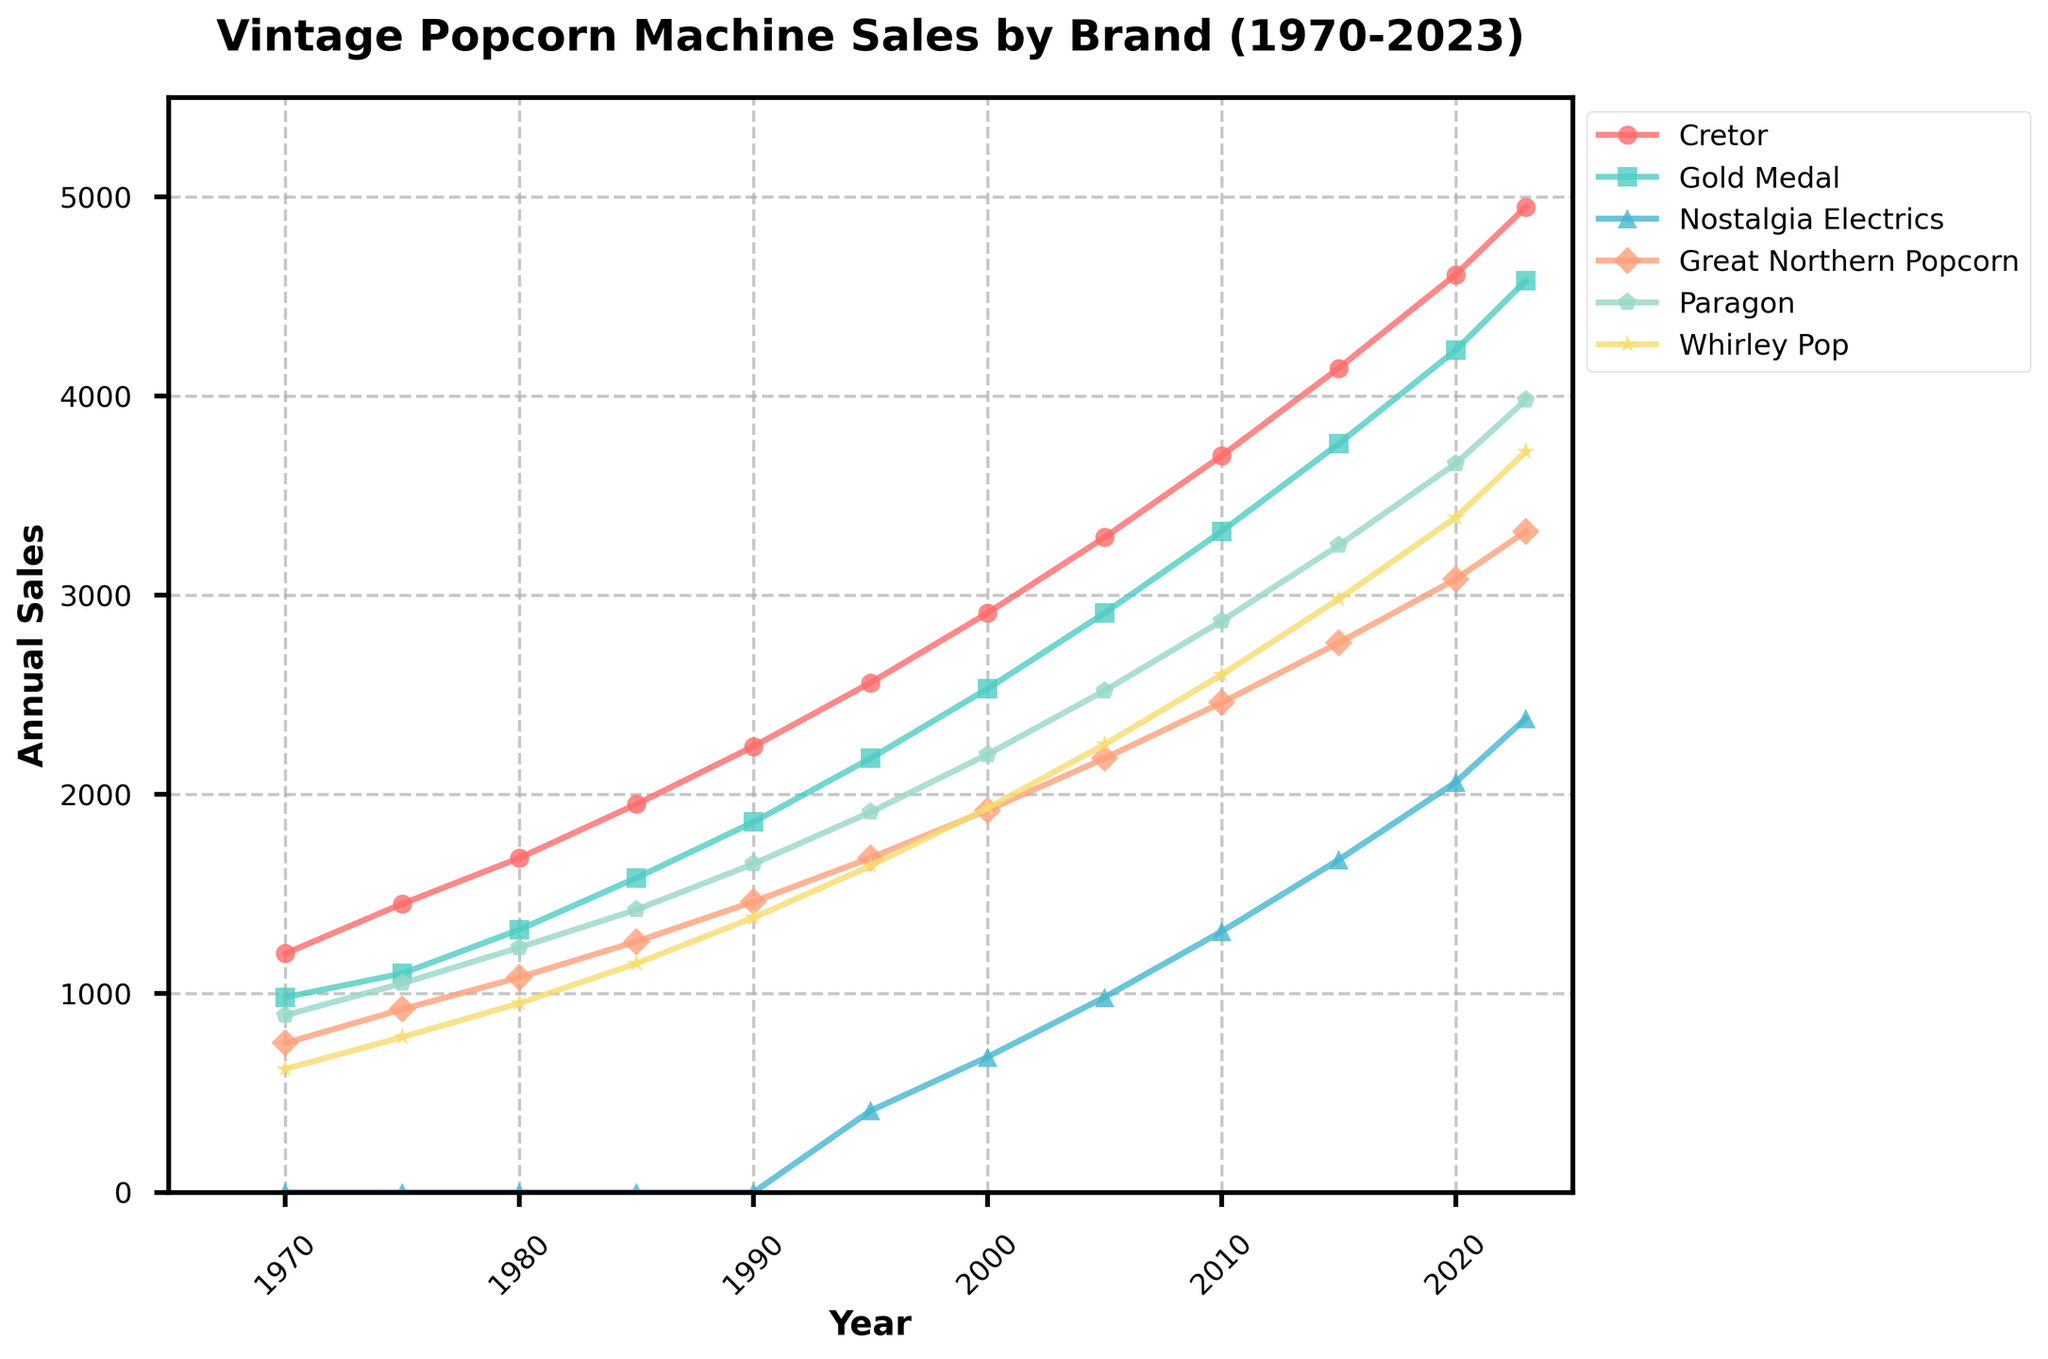Which brand had the highest sales in 2023? Look at the values at the end of each line on the right side of the chart. The highest value is for Cretor.
Answer: Cretor Between 2000 and 2010, which brand saw the largest increase in sales? Examine the lines for each brand between the years 2000 and 2010. Calculate the difference in sales for each brand. Cretor increased from 2910 to 3700, which is the largest difference.
Answer: Cretor How many brands were introduced after 1990? Track the lines starting after 1990. Only Nostalgia Electrics appears after 1990.
Answer: 1 Which brand had the most consistent sales growth over the years? Look for the line that has a steady slope without any sudden spikes or drops. Cretor has the most consistent growth pattern.
Answer: Cretor What was the combined sales of Gold Medal and Paragon in 2015? Find the sales of Gold Medal and Paragon in 2015 on the chart. Gold Medal: 3760 and Paragon: 3250. Combined = 3760 + 3250
Answer: 7010 Did any brand experience a decline in sales at any point? Trace each brand’s line to see if any of them dip downward at any point. None of the brands show a decline; all lines are either stable or upward.
Answer: No Which brand's sales were closest to 3000 in 2010? Look at the 2010 data points: Cretor (3700), Gold Medal (3320), Nostalgia Electrics (1310), Great Northern Popcorn (2460), Paragon (2870), Whirley Pop (2600). The closest to 3000 is Paragon at 2870.
Answer: Paragon What is the difference in sales between the highest and lowest selling brands in 2005? Find the highest and the lowest sales figures in 2005. Cretor (3290) and Nostalgia Electrics (980). The difference is 3290 - 980.
Answer: 2310 Between which years did Whirley Pop see the largest increase in sales? Study the Whirley Pop line and calculate the differences across years. The largest increase is between 2010 (2600) and 2015 (2980), which is 380.
Answer: 2010 to 2015 By how much did the sales of Nostalgia Electrics change from 2000 to 2023? Find the sales of Nostalgia Electrics in 2000 (680) and 2023 (2380). The change is 2380 - 680.
Answer: 1700 